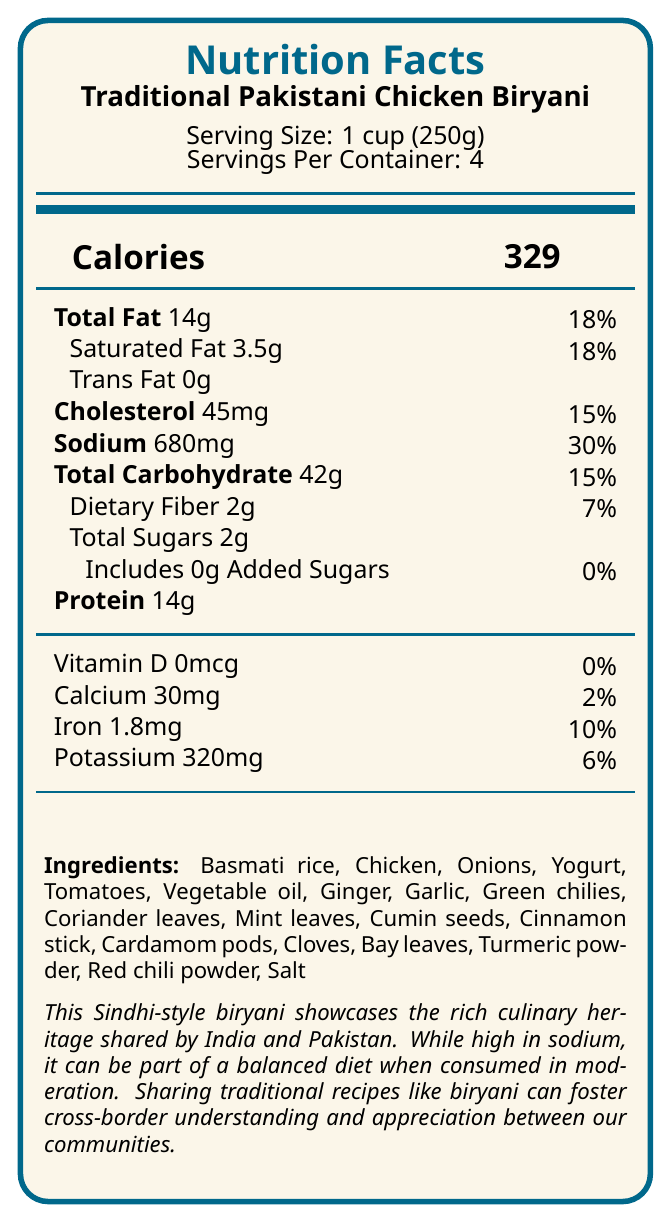what is the serving size? The document specifies the serving size as "1 cup (250g)" under the product information.
Answer: 1 cup (250g) how many calories are in one serving of biryani? The document clearly states "Calories 329" for one serving.
Answer: 329 what percentage of the daily value of sodium does one serving contain? The sodium content per serving is listed as 680mg, which is 30% of the daily value.
Answer: 30% how much protein is there in one serving? The document lists the protein content as 14g per serving.
Answer: 14g what is the total fat content per serving, and its daily value percentage? The document indicates "Total Fat 14g" with a daily value of 18%.
Answer: 14g, 18% which nutrient is present in the highest amount, percentage-wise? A. Saturated Fat B. Cholesterol C. Sodium D. Total Carbohydrate Sodium has the highest percentage of daily value at 30%, compared to other nutrients listed in the document.
Answer: C. Sodium what is the daily value percentage for dietary fiber per serving? The document shows that dietary fiber per serving is 2g, which is 7% of the daily value.
Answer: 7% does the biryani contain any added sugars? Yes or No The document notes that added sugars are 0g, therefore there are no added sugars.
Answer: No which of the following ingredients is not listed in the biryani recipe? A. Coriander leaves B. Potatoes C. Bay leaves The document lists many ingredients, but potatoes are not among them.
Answer: B. Potatoes how much potassium is in one serving? The document specifies the potassium content as 320mg per serving.
Answer: 320mg describe the main idea of the nutrition facts label document. The explanation includes an overview of the document's structure and key information points, including nutritional details, ingredients, cultural significance, and health tips.
Answer: The document provides detailed nutrition information for traditional Pakistani Chicken Biryani. It includes serving size, calories, and various nutrient contents such as fats, cholesterol, sodium, carbohydrates, fiber, sugars, protein, vitamins, and minerals. Additionally, it lists ingredients and offers cultural insights, emphasizing the dish's shared heritage between India and Pakistan and its potential for promoting cross-border understanding. The document also offers a tip to reduce sodium content. what is the regional variation of this biryani? The document mentions that the nutritional information is based on the Sindhi-style biryani, popular in Karachi and surrounding areas.
Answer: This Sindhi-style biryani is popular in Karachi and surrounding areas. what is the daily value percentage for iron in one serving? The document states that the iron content per serving is 1.8mg, which is 10% of the daily value.
Answer: 10% how can the sodium content be reduced while maintaining flavor according to the document? According to the document, the sodium content can be reduced by using less salt and adding more herbs and spices such as mint and coriander.
Answer: Use less salt and enhance flavor with more herbs and spices like mint and coriander. how many servings are there in one container? The document states that there are 4 servings per container.
Answer: 4 what is the daily value percentage of calcium per serving? The document indicates that calcium content per serving is 30mg, which constitutes 2% of the daily value.
Answer: 2% is the amount of trans fat in one serving higher or lower than saturated fat? The document lists trans fat as 0g and saturated fat as 3.5g, making the trans fat significantly lower.
Answer: Lower what is the exact quantity of chicken used in the recipe? The document lists "Chicken" as an ingredient but does not specify the exact quantity used.
Answer: Not enough information 